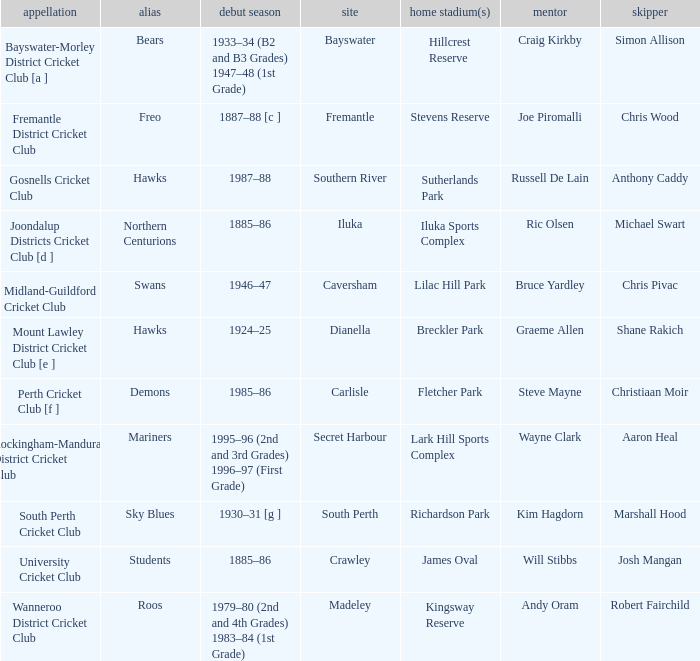For location Caversham, what is the name of the captain? Chris Pivac. 